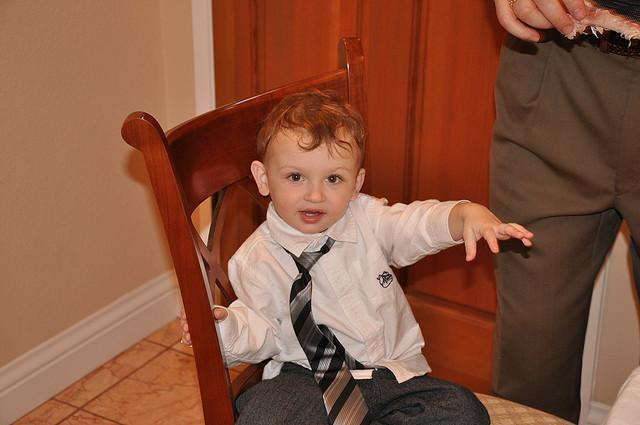What piece of clothing does the boy have on that are meant for adults? tie 